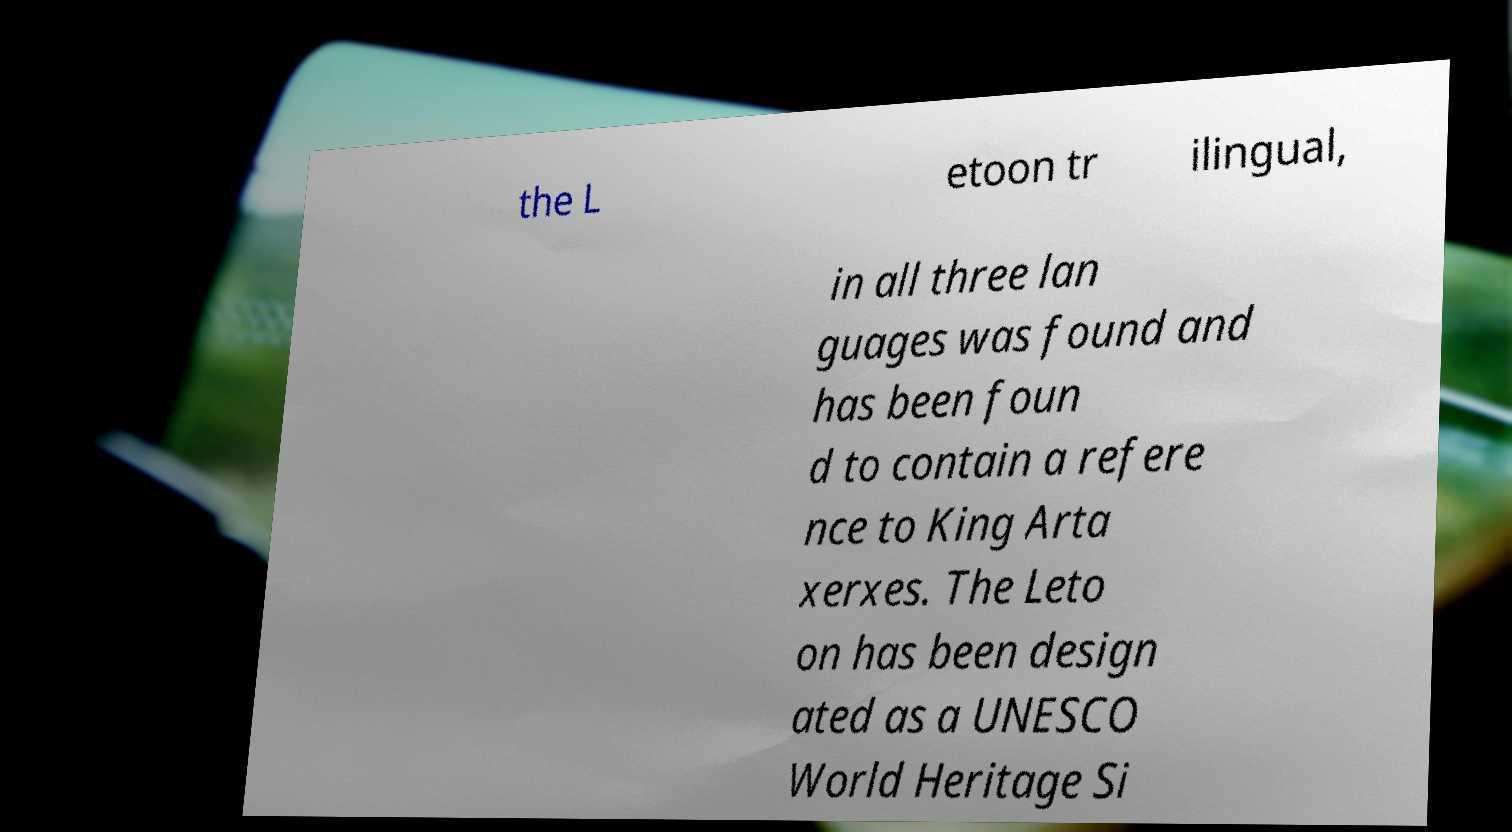Could you extract and type out the text from this image? the L etoon tr ilingual, in all three lan guages was found and has been foun d to contain a refere nce to King Arta xerxes. The Leto on has been design ated as a UNESCO World Heritage Si 